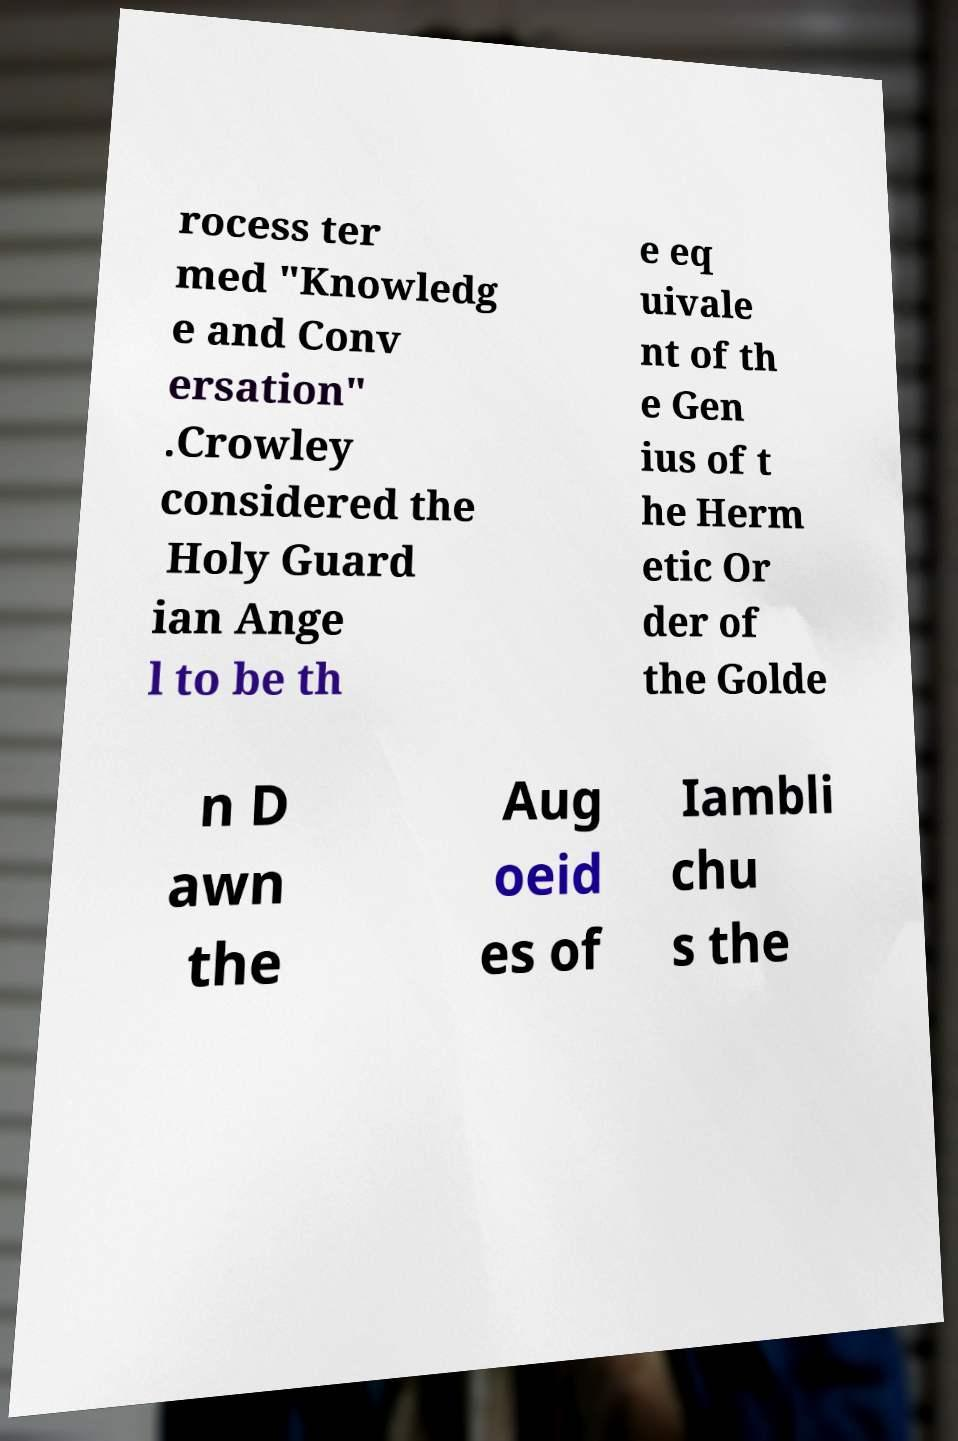For documentation purposes, I need the text within this image transcribed. Could you provide that? rocess ter med "Knowledg e and Conv ersation" .Crowley considered the Holy Guard ian Ange l to be th e eq uivale nt of th e Gen ius of t he Herm etic Or der of the Golde n D awn the Aug oeid es of Iambli chu s the 